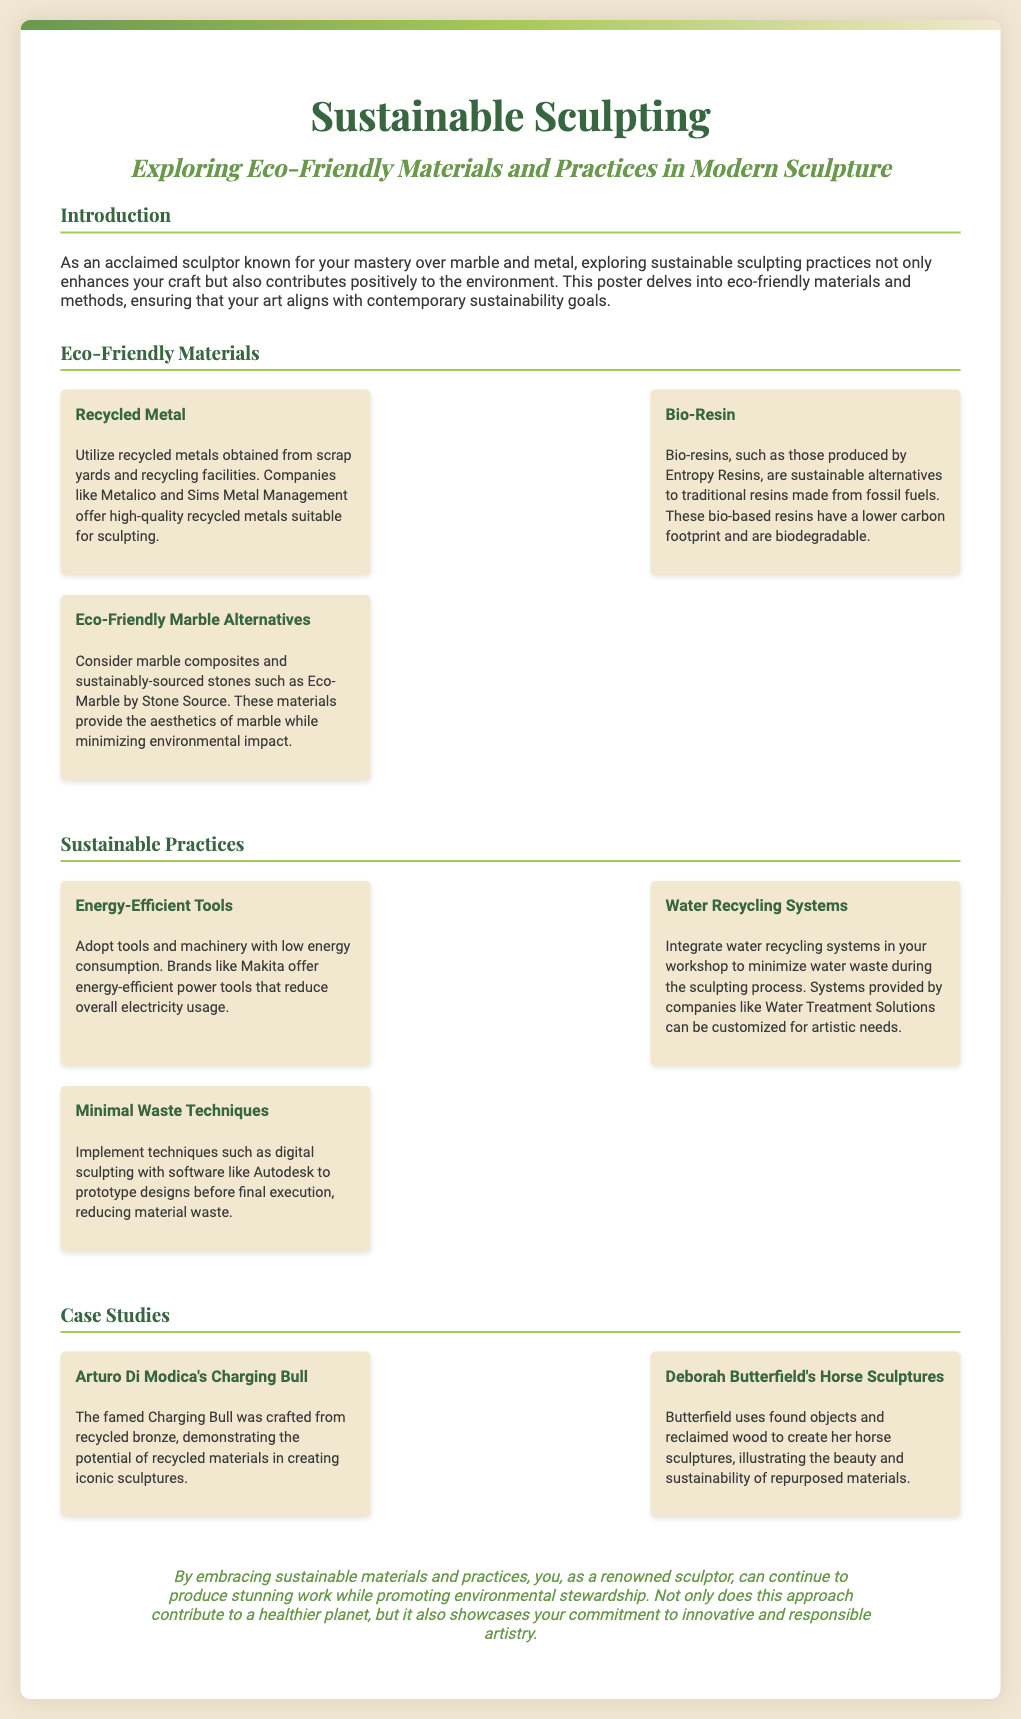what is the title of the poster? The title of the poster is mentioned prominently at the top of the document.
Answer: Sustainable Sculpting who created the Charging Bull sculpture? The document provides the name of the artist who crafted the Charging Bull.
Answer: Arturo Di Modica what material is suggested for eco-friendly marble alternatives? The document lists materials that can serve as alternatives to traditional marble.
Answer: Eco-Marble what is one example of a sustainable practice mentioned? The document highlights various sustainable practices, one of which is described in detail.
Answer: Energy-Efficient Tools how does Deborah Butterfield create her sculptures? The document describes the method and materials used by a specific artist to create her sculptures.
Answer: Found objects and reclaimed wood what is a benefit of using bio-resin? The benefits of eco-friendly materials are discussed in the document, focusing on one in particular.
Answer: Lower carbon footprint name one company mentioned for recycled metals. The document lists companies providing recycled metals suitable for sculpting.
Answer: Metalico which technique minimizes material waste? The document offers techniques that help reduce waste during the sculpting process.
Answer: Digital sculpting what is the primary theme of the poster? The poster's primary aim subject is clearly stated in the introduction section.
Answer: Sustainable sculpting 